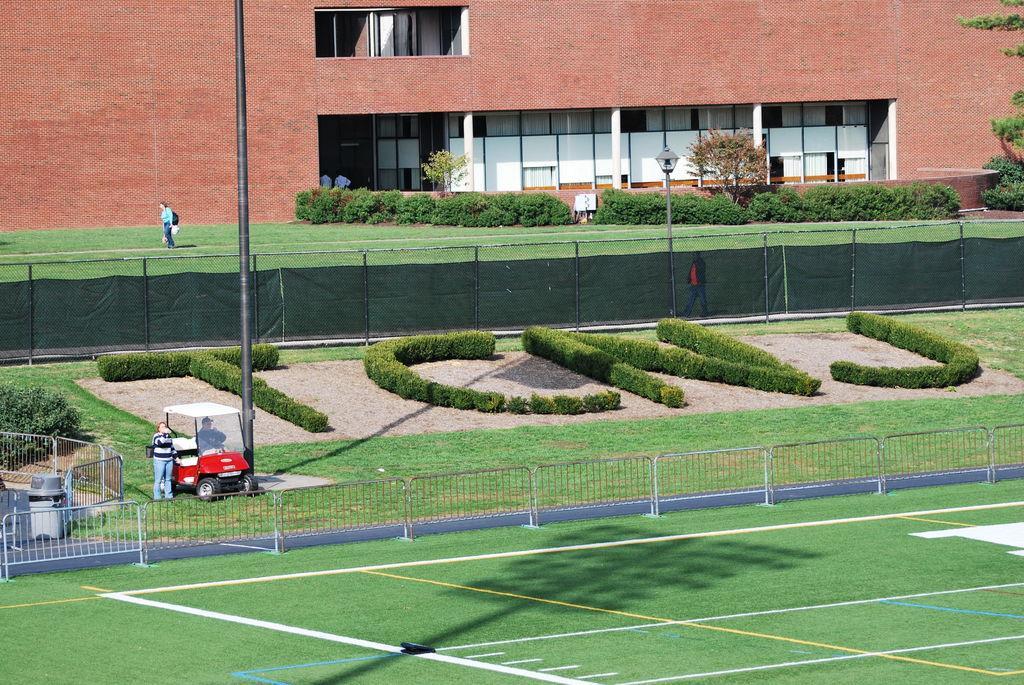In one or two sentences, can you explain what this image depicts? In this picture we can see grass at the bottom, in the background there is a building, we can see barricades, some bushes, plants in the middle, on the left side there is a vehicle, we can see a person is sitting in the vehicle, there is another person standing beside the vehicle, we can see a pole in the middle. 